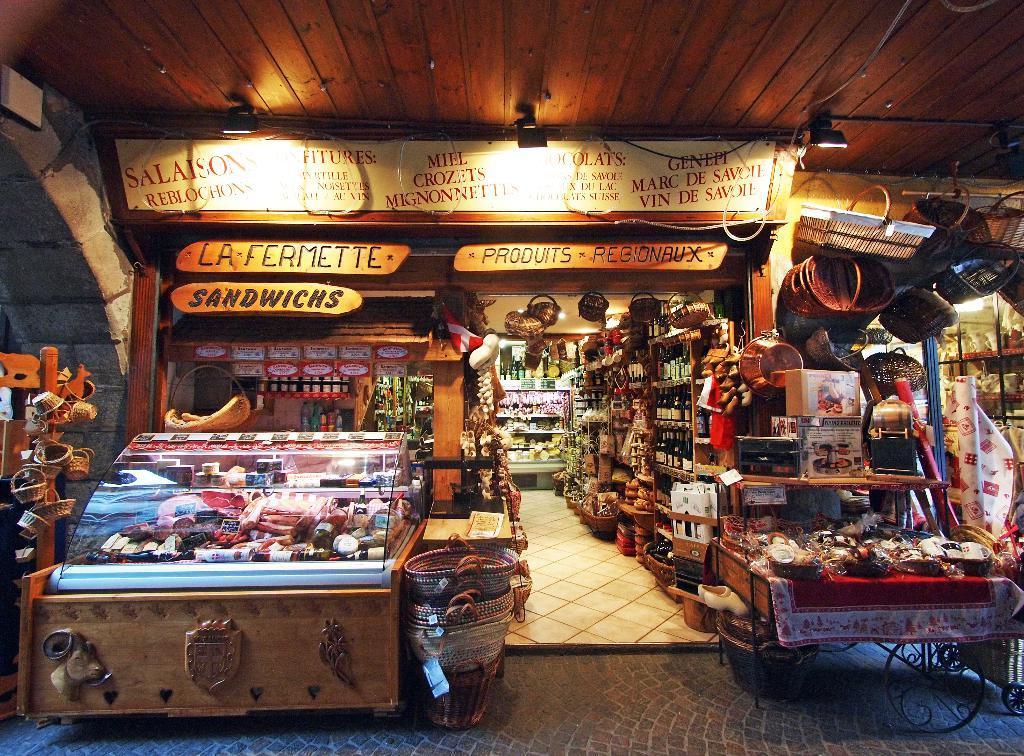<image>
Share a concise interpretation of the image provided. An indoor and outdoor store display that offers sandwichs among other items. 